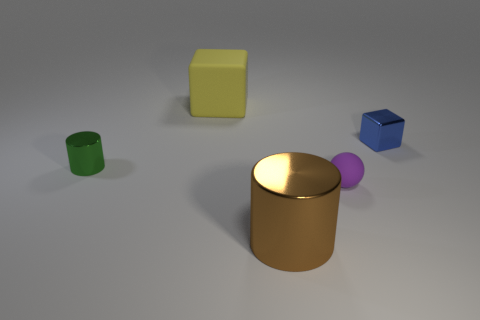What shape is the large thing that is behind the object that is to the left of the block behind the metal cube?
Your answer should be very brief. Cube. What is the size of the cylinder to the left of the large yellow rubber cube?
Give a very brief answer. Small. There is a blue shiny object that is the same size as the purple thing; what shape is it?
Offer a terse response. Cube. What number of objects are either small brown metal objects or objects that are behind the small green metallic cylinder?
Offer a very short reply. 2. There is a yellow matte thing to the left of the metal object that is in front of the green cylinder; what number of yellow cubes are to the left of it?
Make the answer very short. 0. What color is the other cylinder that is made of the same material as the big cylinder?
Provide a succinct answer. Green. Does the matte thing that is to the right of the brown shiny cylinder have the same size as the yellow rubber object?
Provide a succinct answer. No. How many things are either big cyan cylinders or cubes?
Your answer should be very brief. 2. What is the block on the left side of the blue thing behind the tiny thing that is in front of the small shiny cylinder made of?
Your answer should be compact. Rubber. There is a big thing left of the big metallic thing; what is its material?
Offer a very short reply. Rubber. 